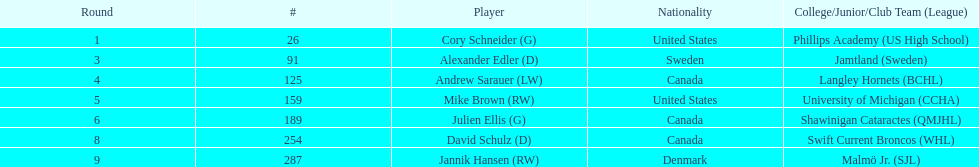How many players were from the united states? 2. 